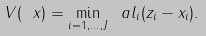Convert formula to latex. <formula><loc_0><loc_0><loc_500><loc_500>V ( \ x ) = \min _ { i = 1 , \dots , J } \ a l _ { i } ( z _ { i } - x _ { i } ) .</formula> 